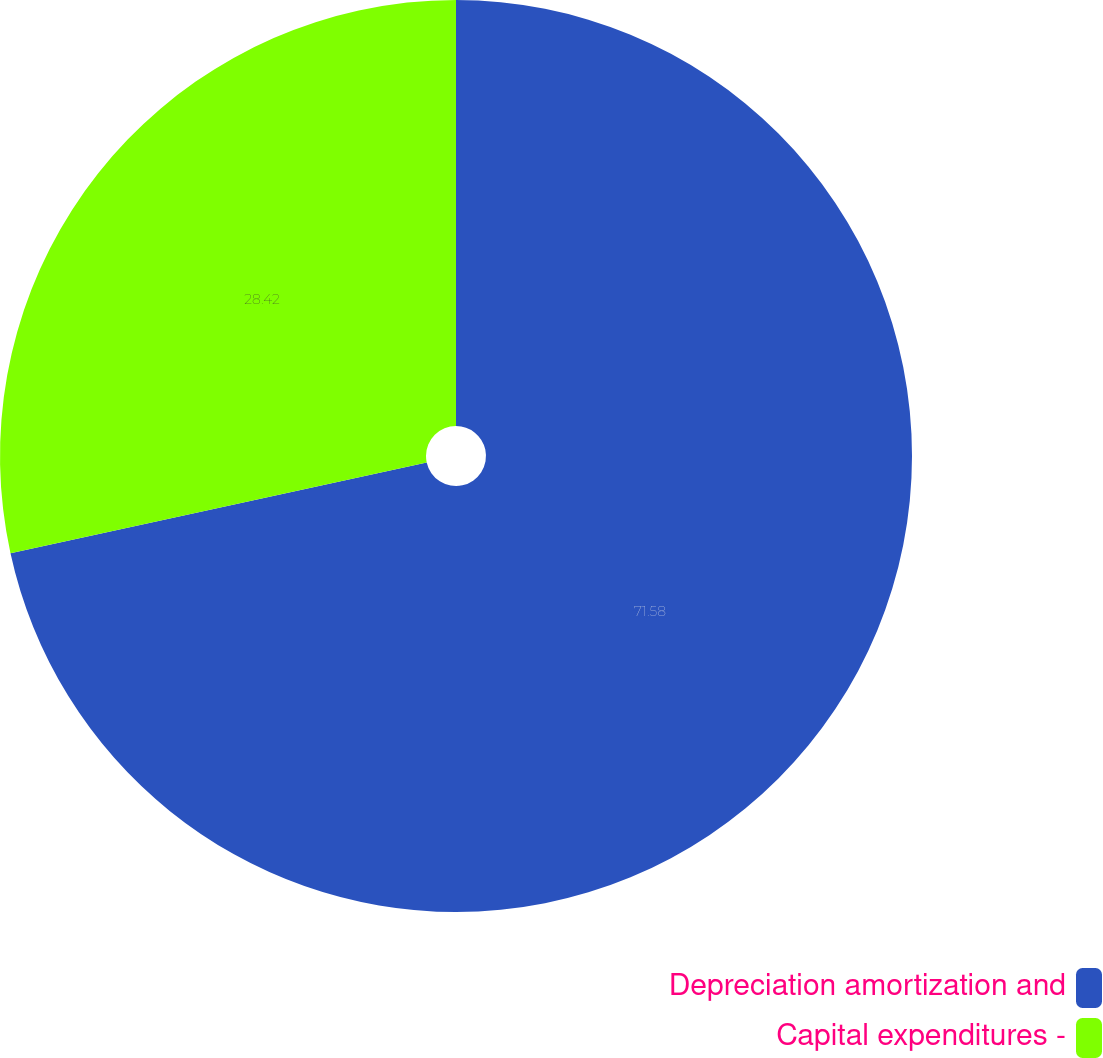Convert chart to OTSL. <chart><loc_0><loc_0><loc_500><loc_500><pie_chart><fcel>Depreciation amortization and<fcel>Capital expenditures -<nl><fcel>71.58%<fcel>28.42%<nl></chart> 